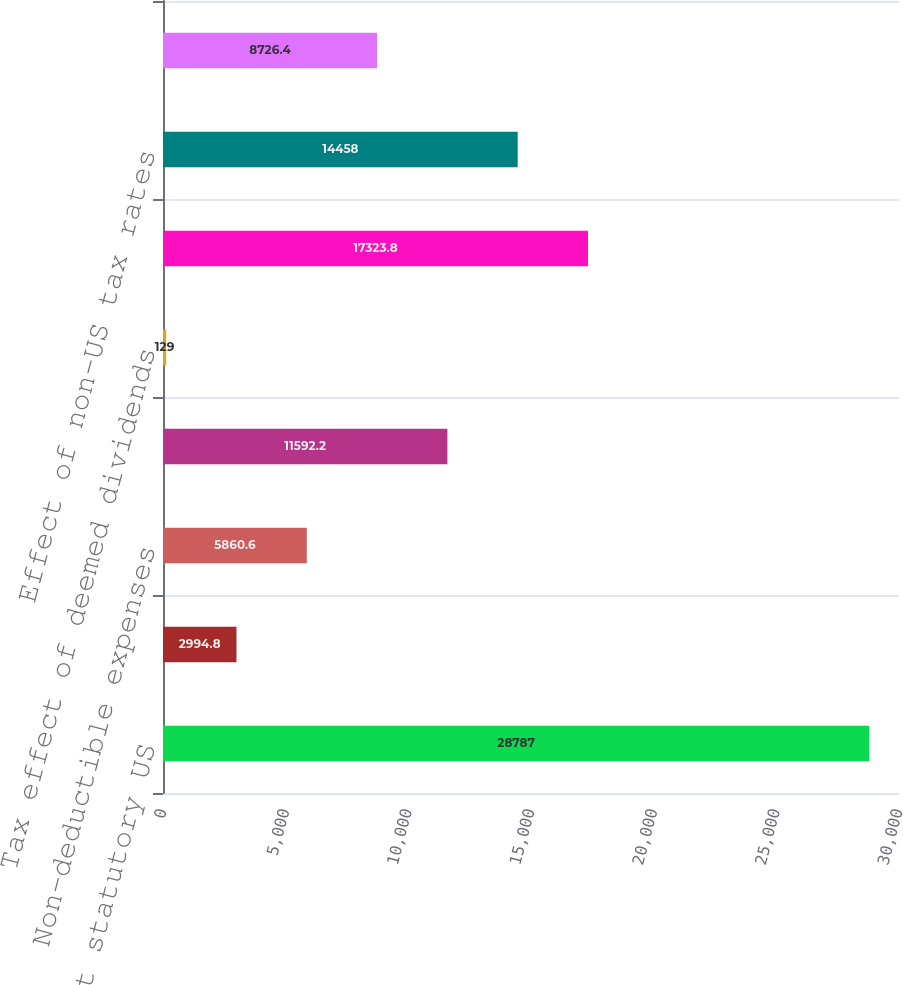Convert chart. <chart><loc_0><loc_0><loc_500><loc_500><bar_chart><fcel>Taxes computed at statutory US<fcel>State income taxes net of US<fcel>Non-deductible expenses<fcel>Research and development<fcel>Tax effect of deemed dividends<fcel>Change in valuation allowance<fcel>Effect of non-US tax rates<fcel>Other<nl><fcel>28787<fcel>2994.8<fcel>5860.6<fcel>11592.2<fcel>129<fcel>17323.8<fcel>14458<fcel>8726.4<nl></chart> 